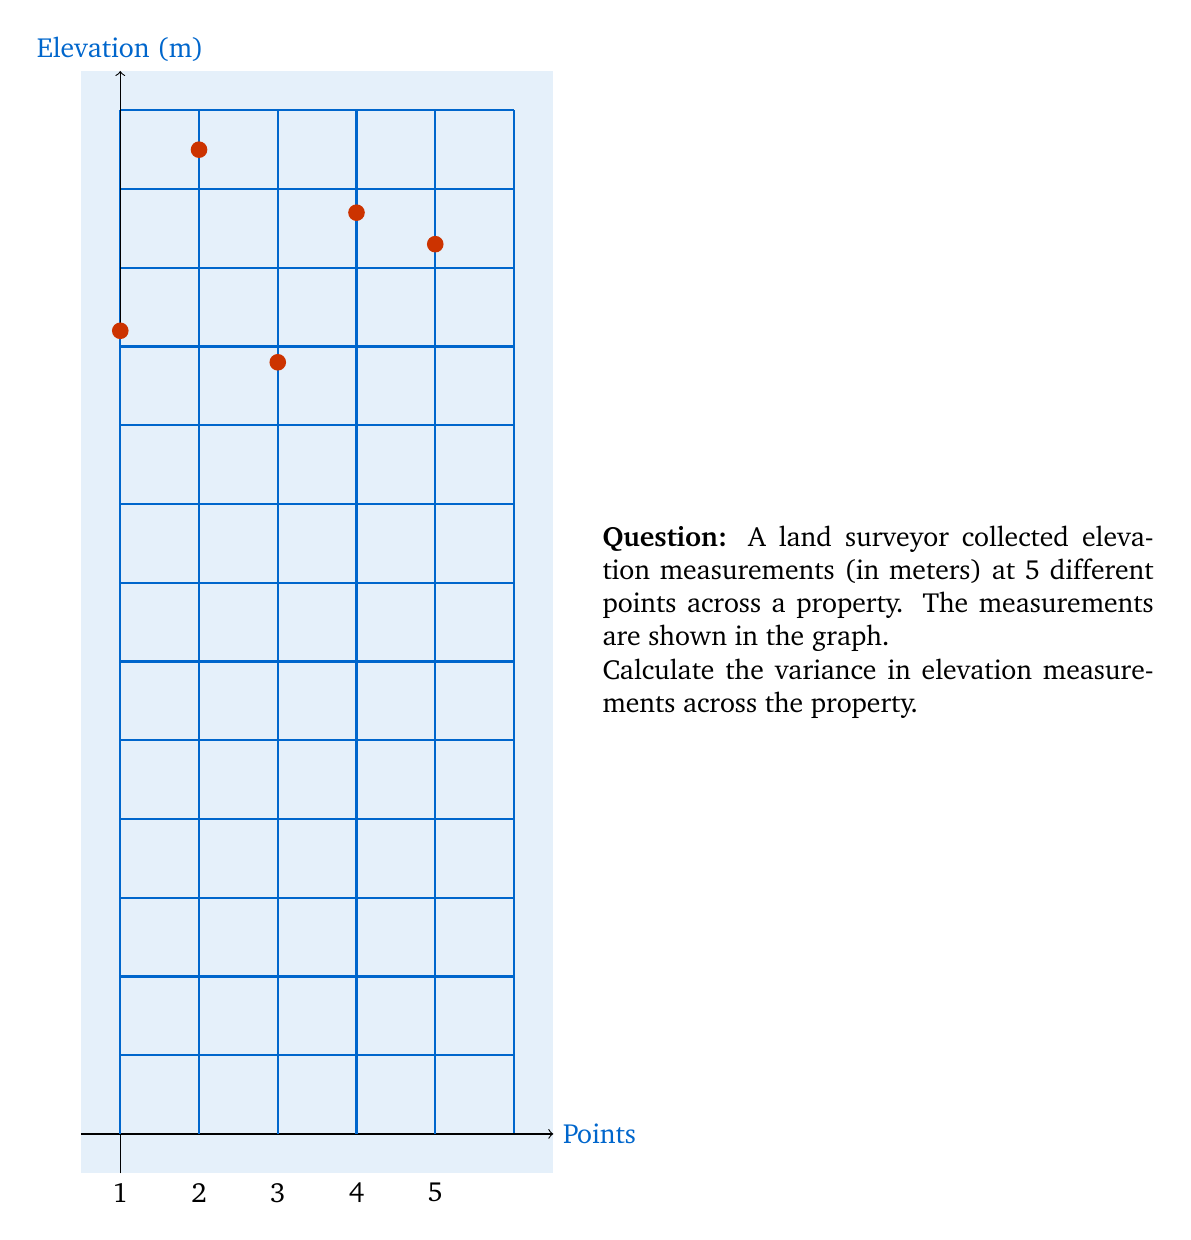Can you answer this question? To calculate the variance, we'll follow these steps:

1) Calculate the mean elevation:
   $$\bar{x} = \frac{10.2 + 12.5 + 9.8 + 11.7 + 11.3}{5} = 11.1\text{ m}$$

2) Calculate the squared differences from the mean:
   $(10.2 - 11.1)^2 = (-0.9)^2 = 0.81$
   $(12.5 - 11.1)^2 = (1.4)^2 = 1.96$
   $(9.8 - 11.1)^2 = (-1.3)^2 = 1.69$
   $(11.7 - 11.1)^2 = (0.6)^2 = 0.36$
   $(11.3 - 11.1)^2 = (0.2)^2 = 0.04$

3) Sum the squared differences:
   $0.81 + 1.96 + 1.69 + 0.36 + 0.04 = 4.86$

4) Divide by (n-1) = 4 to get the variance:
   $$s^2 = \frac{4.86}{4} = 1.215\text{ m}^2$$

Therefore, the variance in elevation measurements is 1.215 m².
Answer: $1.215\text{ m}^2$ 